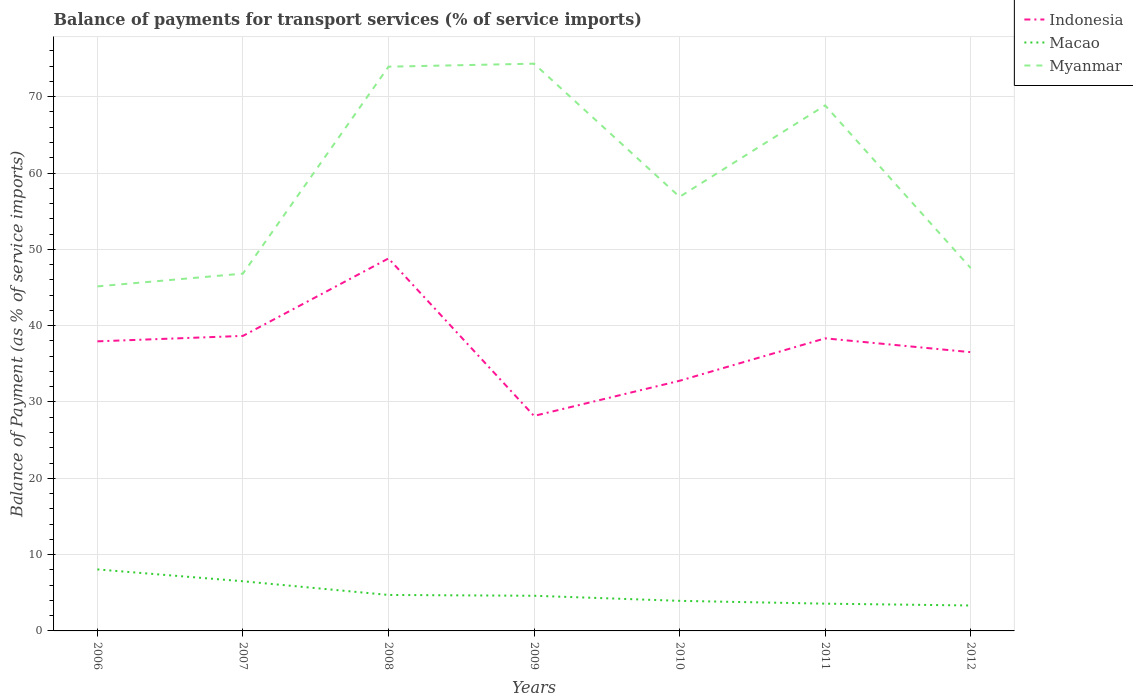How many different coloured lines are there?
Ensure brevity in your answer.  3. Across all years, what is the maximum balance of payments for transport services in Indonesia?
Your answer should be compact. 28.17. What is the total balance of payments for transport services in Myanmar in the graph?
Your answer should be compact. 21.31. What is the difference between the highest and the second highest balance of payments for transport services in Indonesia?
Make the answer very short. 20.63. What is the difference between the highest and the lowest balance of payments for transport services in Macao?
Offer a very short reply. 2. Is the balance of payments for transport services in Macao strictly greater than the balance of payments for transport services in Myanmar over the years?
Give a very brief answer. Yes. What is the difference between two consecutive major ticks on the Y-axis?
Your answer should be compact. 10. Are the values on the major ticks of Y-axis written in scientific E-notation?
Offer a terse response. No. Does the graph contain grids?
Your response must be concise. Yes. Where does the legend appear in the graph?
Make the answer very short. Top right. How many legend labels are there?
Your response must be concise. 3. What is the title of the graph?
Your answer should be compact. Balance of payments for transport services (% of service imports). What is the label or title of the X-axis?
Your response must be concise. Years. What is the label or title of the Y-axis?
Ensure brevity in your answer.  Balance of Payment (as % of service imports). What is the Balance of Payment (as % of service imports) in Indonesia in 2006?
Your response must be concise. 37.94. What is the Balance of Payment (as % of service imports) of Macao in 2006?
Make the answer very short. 8.06. What is the Balance of Payment (as % of service imports) in Myanmar in 2006?
Your answer should be very brief. 45.14. What is the Balance of Payment (as % of service imports) in Indonesia in 2007?
Your response must be concise. 38.66. What is the Balance of Payment (as % of service imports) in Macao in 2007?
Ensure brevity in your answer.  6.51. What is the Balance of Payment (as % of service imports) in Myanmar in 2007?
Ensure brevity in your answer.  46.82. What is the Balance of Payment (as % of service imports) of Indonesia in 2008?
Offer a very short reply. 48.8. What is the Balance of Payment (as % of service imports) of Macao in 2008?
Your answer should be very brief. 4.71. What is the Balance of Payment (as % of service imports) in Myanmar in 2008?
Keep it short and to the point. 73.93. What is the Balance of Payment (as % of service imports) in Indonesia in 2009?
Offer a very short reply. 28.17. What is the Balance of Payment (as % of service imports) in Macao in 2009?
Make the answer very short. 4.61. What is the Balance of Payment (as % of service imports) of Myanmar in 2009?
Keep it short and to the point. 74.33. What is the Balance of Payment (as % of service imports) in Indonesia in 2010?
Your response must be concise. 32.78. What is the Balance of Payment (as % of service imports) in Macao in 2010?
Provide a succinct answer. 3.94. What is the Balance of Payment (as % of service imports) in Myanmar in 2010?
Make the answer very short. 56.88. What is the Balance of Payment (as % of service imports) in Indonesia in 2011?
Give a very brief answer. 38.34. What is the Balance of Payment (as % of service imports) in Macao in 2011?
Give a very brief answer. 3.57. What is the Balance of Payment (as % of service imports) in Myanmar in 2011?
Your answer should be very brief. 68.86. What is the Balance of Payment (as % of service imports) of Indonesia in 2012?
Your response must be concise. 36.53. What is the Balance of Payment (as % of service imports) in Macao in 2012?
Your response must be concise. 3.33. What is the Balance of Payment (as % of service imports) of Myanmar in 2012?
Make the answer very short. 47.55. Across all years, what is the maximum Balance of Payment (as % of service imports) in Indonesia?
Offer a very short reply. 48.8. Across all years, what is the maximum Balance of Payment (as % of service imports) in Macao?
Offer a terse response. 8.06. Across all years, what is the maximum Balance of Payment (as % of service imports) in Myanmar?
Provide a short and direct response. 74.33. Across all years, what is the minimum Balance of Payment (as % of service imports) in Indonesia?
Provide a succinct answer. 28.17. Across all years, what is the minimum Balance of Payment (as % of service imports) of Macao?
Give a very brief answer. 3.33. Across all years, what is the minimum Balance of Payment (as % of service imports) of Myanmar?
Give a very brief answer. 45.14. What is the total Balance of Payment (as % of service imports) of Indonesia in the graph?
Ensure brevity in your answer.  261.21. What is the total Balance of Payment (as % of service imports) in Macao in the graph?
Make the answer very short. 34.73. What is the total Balance of Payment (as % of service imports) in Myanmar in the graph?
Provide a succinct answer. 413.5. What is the difference between the Balance of Payment (as % of service imports) in Indonesia in 2006 and that in 2007?
Ensure brevity in your answer.  -0.71. What is the difference between the Balance of Payment (as % of service imports) in Macao in 2006 and that in 2007?
Your response must be concise. 1.55. What is the difference between the Balance of Payment (as % of service imports) of Myanmar in 2006 and that in 2007?
Ensure brevity in your answer.  -1.67. What is the difference between the Balance of Payment (as % of service imports) of Indonesia in 2006 and that in 2008?
Ensure brevity in your answer.  -10.86. What is the difference between the Balance of Payment (as % of service imports) of Macao in 2006 and that in 2008?
Offer a terse response. 3.35. What is the difference between the Balance of Payment (as % of service imports) in Myanmar in 2006 and that in 2008?
Your answer should be compact. -28.79. What is the difference between the Balance of Payment (as % of service imports) of Indonesia in 2006 and that in 2009?
Ensure brevity in your answer.  9.77. What is the difference between the Balance of Payment (as % of service imports) in Macao in 2006 and that in 2009?
Provide a succinct answer. 3.45. What is the difference between the Balance of Payment (as % of service imports) of Myanmar in 2006 and that in 2009?
Provide a short and direct response. -29.18. What is the difference between the Balance of Payment (as % of service imports) of Indonesia in 2006 and that in 2010?
Your response must be concise. 5.17. What is the difference between the Balance of Payment (as % of service imports) of Macao in 2006 and that in 2010?
Your response must be concise. 4.12. What is the difference between the Balance of Payment (as % of service imports) in Myanmar in 2006 and that in 2010?
Make the answer very short. -11.73. What is the difference between the Balance of Payment (as % of service imports) of Indonesia in 2006 and that in 2011?
Make the answer very short. -0.39. What is the difference between the Balance of Payment (as % of service imports) of Macao in 2006 and that in 2011?
Offer a very short reply. 4.49. What is the difference between the Balance of Payment (as % of service imports) of Myanmar in 2006 and that in 2011?
Make the answer very short. -23.71. What is the difference between the Balance of Payment (as % of service imports) of Indonesia in 2006 and that in 2012?
Your answer should be compact. 1.42. What is the difference between the Balance of Payment (as % of service imports) of Macao in 2006 and that in 2012?
Provide a succinct answer. 4.73. What is the difference between the Balance of Payment (as % of service imports) in Myanmar in 2006 and that in 2012?
Your answer should be very brief. -2.4. What is the difference between the Balance of Payment (as % of service imports) of Indonesia in 2007 and that in 2008?
Give a very brief answer. -10.15. What is the difference between the Balance of Payment (as % of service imports) in Macao in 2007 and that in 2008?
Provide a short and direct response. 1.79. What is the difference between the Balance of Payment (as % of service imports) of Myanmar in 2007 and that in 2008?
Provide a succinct answer. -27.11. What is the difference between the Balance of Payment (as % of service imports) of Indonesia in 2007 and that in 2009?
Provide a succinct answer. 10.48. What is the difference between the Balance of Payment (as % of service imports) in Macao in 2007 and that in 2009?
Provide a short and direct response. 1.9. What is the difference between the Balance of Payment (as % of service imports) in Myanmar in 2007 and that in 2009?
Your answer should be very brief. -27.51. What is the difference between the Balance of Payment (as % of service imports) in Indonesia in 2007 and that in 2010?
Provide a short and direct response. 5.88. What is the difference between the Balance of Payment (as % of service imports) in Macao in 2007 and that in 2010?
Keep it short and to the point. 2.57. What is the difference between the Balance of Payment (as % of service imports) of Myanmar in 2007 and that in 2010?
Give a very brief answer. -10.06. What is the difference between the Balance of Payment (as % of service imports) of Indonesia in 2007 and that in 2011?
Your answer should be very brief. 0.32. What is the difference between the Balance of Payment (as % of service imports) in Macao in 2007 and that in 2011?
Make the answer very short. 2.93. What is the difference between the Balance of Payment (as % of service imports) of Myanmar in 2007 and that in 2011?
Your answer should be compact. -22.04. What is the difference between the Balance of Payment (as % of service imports) of Indonesia in 2007 and that in 2012?
Provide a succinct answer. 2.13. What is the difference between the Balance of Payment (as % of service imports) of Macao in 2007 and that in 2012?
Provide a succinct answer. 3.17. What is the difference between the Balance of Payment (as % of service imports) of Myanmar in 2007 and that in 2012?
Provide a short and direct response. -0.73. What is the difference between the Balance of Payment (as % of service imports) in Indonesia in 2008 and that in 2009?
Ensure brevity in your answer.  20.63. What is the difference between the Balance of Payment (as % of service imports) of Macao in 2008 and that in 2009?
Give a very brief answer. 0.11. What is the difference between the Balance of Payment (as % of service imports) of Myanmar in 2008 and that in 2009?
Ensure brevity in your answer.  -0.4. What is the difference between the Balance of Payment (as % of service imports) of Indonesia in 2008 and that in 2010?
Keep it short and to the point. 16.03. What is the difference between the Balance of Payment (as % of service imports) of Macao in 2008 and that in 2010?
Ensure brevity in your answer.  0.77. What is the difference between the Balance of Payment (as % of service imports) in Myanmar in 2008 and that in 2010?
Ensure brevity in your answer.  17.05. What is the difference between the Balance of Payment (as % of service imports) in Indonesia in 2008 and that in 2011?
Your answer should be compact. 10.47. What is the difference between the Balance of Payment (as % of service imports) of Macao in 2008 and that in 2011?
Make the answer very short. 1.14. What is the difference between the Balance of Payment (as % of service imports) in Myanmar in 2008 and that in 2011?
Offer a terse response. 5.07. What is the difference between the Balance of Payment (as % of service imports) of Indonesia in 2008 and that in 2012?
Your answer should be compact. 12.28. What is the difference between the Balance of Payment (as % of service imports) in Macao in 2008 and that in 2012?
Offer a very short reply. 1.38. What is the difference between the Balance of Payment (as % of service imports) of Myanmar in 2008 and that in 2012?
Offer a very short reply. 26.39. What is the difference between the Balance of Payment (as % of service imports) of Indonesia in 2009 and that in 2010?
Ensure brevity in your answer.  -4.6. What is the difference between the Balance of Payment (as % of service imports) of Macao in 2009 and that in 2010?
Offer a terse response. 0.67. What is the difference between the Balance of Payment (as % of service imports) in Myanmar in 2009 and that in 2010?
Give a very brief answer. 17.45. What is the difference between the Balance of Payment (as % of service imports) of Indonesia in 2009 and that in 2011?
Make the answer very short. -10.16. What is the difference between the Balance of Payment (as % of service imports) of Macao in 2009 and that in 2011?
Provide a succinct answer. 1.03. What is the difference between the Balance of Payment (as % of service imports) in Myanmar in 2009 and that in 2011?
Your answer should be very brief. 5.47. What is the difference between the Balance of Payment (as % of service imports) of Indonesia in 2009 and that in 2012?
Your answer should be compact. -8.35. What is the difference between the Balance of Payment (as % of service imports) of Macao in 2009 and that in 2012?
Offer a very short reply. 1.27. What is the difference between the Balance of Payment (as % of service imports) in Myanmar in 2009 and that in 2012?
Keep it short and to the point. 26.78. What is the difference between the Balance of Payment (as % of service imports) of Indonesia in 2010 and that in 2011?
Your answer should be very brief. -5.56. What is the difference between the Balance of Payment (as % of service imports) of Macao in 2010 and that in 2011?
Your response must be concise. 0.37. What is the difference between the Balance of Payment (as % of service imports) of Myanmar in 2010 and that in 2011?
Keep it short and to the point. -11.98. What is the difference between the Balance of Payment (as % of service imports) of Indonesia in 2010 and that in 2012?
Ensure brevity in your answer.  -3.75. What is the difference between the Balance of Payment (as % of service imports) of Macao in 2010 and that in 2012?
Provide a short and direct response. 0.61. What is the difference between the Balance of Payment (as % of service imports) in Myanmar in 2010 and that in 2012?
Give a very brief answer. 9.33. What is the difference between the Balance of Payment (as % of service imports) in Indonesia in 2011 and that in 2012?
Offer a terse response. 1.81. What is the difference between the Balance of Payment (as % of service imports) in Macao in 2011 and that in 2012?
Provide a short and direct response. 0.24. What is the difference between the Balance of Payment (as % of service imports) in Myanmar in 2011 and that in 2012?
Your answer should be very brief. 21.31. What is the difference between the Balance of Payment (as % of service imports) in Indonesia in 2006 and the Balance of Payment (as % of service imports) in Macao in 2007?
Your answer should be compact. 31.44. What is the difference between the Balance of Payment (as % of service imports) in Indonesia in 2006 and the Balance of Payment (as % of service imports) in Myanmar in 2007?
Offer a terse response. -8.87. What is the difference between the Balance of Payment (as % of service imports) of Macao in 2006 and the Balance of Payment (as % of service imports) of Myanmar in 2007?
Provide a succinct answer. -38.76. What is the difference between the Balance of Payment (as % of service imports) in Indonesia in 2006 and the Balance of Payment (as % of service imports) in Macao in 2008?
Ensure brevity in your answer.  33.23. What is the difference between the Balance of Payment (as % of service imports) in Indonesia in 2006 and the Balance of Payment (as % of service imports) in Myanmar in 2008?
Offer a very short reply. -35.99. What is the difference between the Balance of Payment (as % of service imports) in Macao in 2006 and the Balance of Payment (as % of service imports) in Myanmar in 2008?
Give a very brief answer. -65.87. What is the difference between the Balance of Payment (as % of service imports) of Indonesia in 2006 and the Balance of Payment (as % of service imports) of Macao in 2009?
Your response must be concise. 33.34. What is the difference between the Balance of Payment (as % of service imports) in Indonesia in 2006 and the Balance of Payment (as % of service imports) in Myanmar in 2009?
Your answer should be very brief. -36.38. What is the difference between the Balance of Payment (as % of service imports) of Macao in 2006 and the Balance of Payment (as % of service imports) of Myanmar in 2009?
Give a very brief answer. -66.27. What is the difference between the Balance of Payment (as % of service imports) of Indonesia in 2006 and the Balance of Payment (as % of service imports) of Macao in 2010?
Offer a very short reply. 34. What is the difference between the Balance of Payment (as % of service imports) of Indonesia in 2006 and the Balance of Payment (as % of service imports) of Myanmar in 2010?
Provide a short and direct response. -18.93. What is the difference between the Balance of Payment (as % of service imports) in Macao in 2006 and the Balance of Payment (as % of service imports) in Myanmar in 2010?
Provide a short and direct response. -48.82. What is the difference between the Balance of Payment (as % of service imports) of Indonesia in 2006 and the Balance of Payment (as % of service imports) of Macao in 2011?
Provide a succinct answer. 34.37. What is the difference between the Balance of Payment (as % of service imports) of Indonesia in 2006 and the Balance of Payment (as % of service imports) of Myanmar in 2011?
Offer a terse response. -30.92. What is the difference between the Balance of Payment (as % of service imports) of Macao in 2006 and the Balance of Payment (as % of service imports) of Myanmar in 2011?
Make the answer very short. -60.8. What is the difference between the Balance of Payment (as % of service imports) in Indonesia in 2006 and the Balance of Payment (as % of service imports) in Macao in 2012?
Ensure brevity in your answer.  34.61. What is the difference between the Balance of Payment (as % of service imports) of Indonesia in 2006 and the Balance of Payment (as % of service imports) of Myanmar in 2012?
Your answer should be compact. -9.6. What is the difference between the Balance of Payment (as % of service imports) of Macao in 2006 and the Balance of Payment (as % of service imports) of Myanmar in 2012?
Your response must be concise. -39.49. What is the difference between the Balance of Payment (as % of service imports) of Indonesia in 2007 and the Balance of Payment (as % of service imports) of Macao in 2008?
Make the answer very short. 33.94. What is the difference between the Balance of Payment (as % of service imports) of Indonesia in 2007 and the Balance of Payment (as % of service imports) of Myanmar in 2008?
Ensure brevity in your answer.  -35.27. What is the difference between the Balance of Payment (as % of service imports) of Macao in 2007 and the Balance of Payment (as % of service imports) of Myanmar in 2008?
Keep it short and to the point. -67.42. What is the difference between the Balance of Payment (as % of service imports) of Indonesia in 2007 and the Balance of Payment (as % of service imports) of Macao in 2009?
Provide a succinct answer. 34.05. What is the difference between the Balance of Payment (as % of service imports) of Indonesia in 2007 and the Balance of Payment (as % of service imports) of Myanmar in 2009?
Offer a very short reply. -35.67. What is the difference between the Balance of Payment (as % of service imports) of Macao in 2007 and the Balance of Payment (as % of service imports) of Myanmar in 2009?
Your response must be concise. -67.82. What is the difference between the Balance of Payment (as % of service imports) in Indonesia in 2007 and the Balance of Payment (as % of service imports) in Macao in 2010?
Keep it short and to the point. 34.71. What is the difference between the Balance of Payment (as % of service imports) of Indonesia in 2007 and the Balance of Payment (as % of service imports) of Myanmar in 2010?
Provide a succinct answer. -18.22. What is the difference between the Balance of Payment (as % of service imports) of Macao in 2007 and the Balance of Payment (as % of service imports) of Myanmar in 2010?
Provide a short and direct response. -50.37. What is the difference between the Balance of Payment (as % of service imports) of Indonesia in 2007 and the Balance of Payment (as % of service imports) of Macao in 2011?
Ensure brevity in your answer.  35.08. What is the difference between the Balance of Payment (as % of service imports) in Indonesia in 2007 and the Balance of Payment (as % of service imports) in Myanmar in 2011?
Provide a succinct answer. -30.2. What is the difference between the Balance of Payment (as % of service imports) of Macao in 2007 and the Balance of Payment (as % of service imports) of Myanmar in 2011?
Offer a terse response. -62.35. What is the difference between the Balance of Payment (as % of service imports) in Indonesia in 2007 and the Balance of Payment (as % of service imports) in Macao in 2012?
Provide a succinct answer. 35.32. What is the difference between the Balance of Payment (as % of service imports) of Indonesia in 2007 and the Balance of Payment (as % of service imports) of Myanmar in 2012?
Provide a succinct answer. -8.89. What is the difference between the Balance of Payment (as % of service imports) of Macao in 2007 and the Balance of Payment (as % of service imports) of Myanmar in 2012?
Your response must be concise. -41.04. What is the difference between the Balance of Payment (as % of service imports) of Indonesia in 2008 and the Balance of Payment (as % of service imports) of Macao in 2009?
Offer a very short reply. 44.2. What is the difference between the Balance of Payment (as % of service imports) in Indonesia in 2008 and the Balance of Payment (as % of service imports) in Myanmar in 2009?
Keep it short and to the point. -25.52. What is the difference between the Balance of Payment (as % of service imports) of Macao in 2008 and the Balance of Payment (as % of service imports) of Myanmar in 2009?
Your response must be concise. -69.61. What is the difference between the Balance of Payment (as % of service imports) in Indonesia in 2008 and the Balance of Payment (as % of service imports) in Macao in 2010?
Offer a terse response. 44.86. What is the difference between the Balance of Payment (as % of service imports) of Indonesia in 2008 and the Balance of Payment (as % of service imports) of Myanmar in 2010?
Give a very brief answer. -8.07. What is the difference between the Balance of Payment (as % of service imports) of Macao in 2008 and the Balance of Payment (as % of service imports) of Myanmar in 2010?
Provide a short and direct response. -52.16. What is the difference between the Balance of Payment (as % of service imports) of Indonesia in 2008 and the Balance of Payment (as % of service imports) of Macao in 2011?
Provide a succinct answer. 45.23. What is the difference between the Balance of Payment (as % of service imports) of Indonesia in 2008 and the Balance of Payment (as % of service imports) of Myanmar in 2011?
Provide a short and direct response. -20.05. What is the difference between the Balance of Payment (as % of service imports) of Macao in 2008 and the Balance of Payment (as % of service imports) of Myanmar in 2011?
Your answer should be very brief. -64.15. What is the difference between the Balance of Payment (as % of service imports) of Indonesia in 2008 and the Balance of Payment (as % of service imports) of Macao in 2012?
Your answer should be very brief. 45.47. What is the difference between the Balance of Payment (as % of service imports) of Indonesia in 2008 and the Balance of Payment (as % of service imports) of Myanmar in 2012?
Keep it short and to the point. 1.26. What is the difference between the Balance of Payment (as % of service imports) in Macao in 2008 and the Balance of Payment (as % of service imports) in Myanmar in 2012?
Provide a succinct answer. -42.83. What is the difference between the Balance of Payment (as % of service imports) of Indonesia in 2009 and the Balance of Payment (as % of service imports) of Macao in 2010?
Your answer should be compact. 24.23. What is the difference between the Balance of Payment (as % of service imports) of Indonesia in 2009 and the Balance of Payment (as % of service imports) of Myanmar in 2010?
Your answer should be very brief. -28.7. What is the difference between the Balance of Payment (as % of service imports) in Macao in 2009 and the Balance of Payment (as % of service imports) in Myanmar in 2010?
Your response must be concise. -52.27. What is the difference between the Balance of Payment (as % of service imports) of Indonesia in 2009 and the Balance of Payment (as % of service imports) of Macao in 2011?
Ensure brevity in your answer.  24.6. What is the difference between the Balance of Payment (as % of service imports) of Indonesia in 2009 and the Balance of Payment (as % of service imports) of Myanmar in 2011?
Ensure brevity in your answer.  -40.69. What is the difference between the Balance of Payment (as % of service imports) in Macao in 2009 and the Balance of Payment (as % of service imports) in Myanmar in 2011?
Your response must be concise. -64.25. What is the difference between the Balance of Payment (as % of service imports) of Indonesia in 2009 and the Balance of Payment (as % of service imports) of Macao in 2012?
Make the answer very short. 24.84. What is the difference between the Balance of Payment (as % of service imports) of Indonesia in 2009 and the Balance of Payment (as % of service imports) of Myanmar in 2012?
Offer a terse response. -19.37. What is the difference between the Balance of Payment (as % of service imports) in Macao in 2009 and the Balance of Payment (as % of service imports) in Myanmar in 2012?
Give a very brief answer. -42.94. What is the difference between the Balance of Payment (as % of service imports) of Indonesia in 2010 and the Balance of Payment (as % of service imports) of Macao in 2011?
Your answer should be very brief. 29.2. What is the difference between the Balance of Payment (as % of service imports) in Indonesia in 2010 and the Balance of Payment (as % of service imports) in Myanmar in 2011?
Ensure brevity in your answer.  -36.08. What is the difference between the Balance of Payment (as % of service imports) in Macao in 2010 and the Balance of Payment (as % of service imports) in Myanmar in 2011?
Provide a short and direct response. -64.92. What is the difference between the Balance of Payment (as % of service imports) of Indonesia in 2010 and the Balance of Payment (as % of service imports) of Macao in 2012?
Offer a terse response. 29.44. What is the difference between the Balance of Payment (as % of service imports) in Indonesia in 2010 and the Balance of Payment (as % of service imports) in Myanmar in 2012?
Provide a short and direct response. -14.77. What is the difference between the Balance of Payment (as % of service imports) of Macao in 2010 and the Balance of Payment (as % of service imports) of Myanmar in 2012?
Give a very brief answer. -43.6. What is the difference between the Balance of Payment (as % of service imports) in Indonesia in 2011 and the Balance of Payment (as % of service imports) in Macao in 2012?
Provide a short and direct response. 35. What is the difference between the Balance of Payment (as % of service imports) in Indonesia in 2011 and the Balance of Payment (as % of service imports) in Myanmar in 2012?
Your response must be concise. -9.21. What is the difference between the Balance of Payment (as % of service imports) of Macao in 2011 and the Balance of Payment (as % of service imports) of Myanmar in 2012?
Provide a succinct answer. -43.97. What is the average Balance of Payment (as % of service imports) in Indonesia per year?
Keep it short and to the point. 37.32. What is the average Balance of Payment (as % of service imports) in Macao per year?
Offer a terse response. 4.96. What is the average Balance of Payment (as % of service imports) in Myanmar per year?
Provide a short and direct response. 59.07. In the year 2006, what is the difference between the Balance of Payment (as % of service imports) of Indonesia and Balance of Payment (as % of service imports) of Macao?
Your response must be concise. 29.88. In the year 2006, what is the difference between the Balance of Payment (as % of service imports) in Indonesia and Balance of Payment (as % of service imports) in Myanmar?
Your answer should be very brief. -7.2. In the year 2006, what is the difference between the Balance of Payment (as % of service imports) in Macao and Balance of Payment (as % of service imports) in Myanmar?
Your response must be concise. -37.09. In the year 2007, what is the difference between the Balance of Payment (as % of service imports) of Indonesia and Balance of Payment (as % of service imports) of Macao?
Keep it short and to the point. 32.15. In the year 2007, what is the difference between the Balance of Payment (as % of service imports) in Indonesia and Balance of Payment (as % of service imports) in Myanmar?
Provide a succinct answer. -8.16. In the year 2007, what is the difference between the Balance of Payment (as % of service imports) of Macao and Balance of Payment (as % of service imports) of Myanmar?
Your response must be concise. -40.31. In the year 2008, what is the difference between the Balance of Payment (as % of service imports) in Indonesia and Balance of Payment (as % of service imports) in Macao?
Your response must be concise. 44.09. In the year 2008, what is the difference between the Balance of Payment (as % of service imports) of Indonesia and Balance of Payment (as % of service imports) of Myanmar?
Provide a succinct answer. -25.13. In the year 2008, what is the difference between the Balance of Payment (as % of service imports) of Macao and Balance of Payment (as % of service imports) of Myanmar?
Your answer should be compact. -69.22. In the year 2009, what is the difference between the Balance of Payment (as % of service imports) in Indonesia and Balance of Payment (as % of service imports) in Macao?
Offer a very short reply. 23.57. In the year 2009, what is the difference between the Balance of Payment (as % of service imports) in Indonesia and Balance of Payment (as % of service imports) in Myanmar?
Provide a short and direct response. -46.15. In the year 2009, what is the difference between the Balance of Payment (as % of service imports) in Macao and Balance of Payment (as % of service imports) in Myanmar?
Provide a succinct answer. -69.72. In the year 2010, what is the difference between the Balance of Payment (as % of service imports) in Indonesia and Balance of Payment (as % of service imports) in Macao?
Provide a short and direct response. 28.83. In the year 2010, what is the difference between the Balance of Payment (as % of service imports) of Indonesia and Balance of Payment (as % of service imports) of Myanmar?
Your answer should be compact. -24.1. In the year 2010, what is the difference between the Balance of Payment (as % of service imports) in Macao and Balance of Payment (as % of service imports) in Myanmar?
Your answer should be very brief. -52.94. In the year 2011, what is the difference between the Balance of Payment (as % of service imports) of Indonesia and Balance of Payment (as % of service imports) of Macao?
Offer a very short reply. 34.76. In the year 2011, what is the difference between the Balance of Payment (as % of service imports) of Indonesia and Balance of Payment (as % of service imports) of Myanmar?
Your response must be concise. -30.52. In the year 2011, what is the difference between the Balance of Payment (as % of service imports) of Macao and Balance of Payment (as % of service imports) of Myanmar?
Give a very brief answer. -65.29. In the year 2012, what is the difference between the Balance of Payment (as % of service imports) in Indonesia and Balance of Payment (as % of service imports) in Macao?
Make the answer very short. 33.19. In the year 2012, what is the difference between the Balance of Payment (as % of service imports) of Indonesia and Balance of Payment (as % of service imports) of Myanmar?
Offer a terse response. -11.02. In the year 2012, what is the difference between the Balance of Payment (as % of service imports) in Macao and Balance of Payment (as % of service imports) in Myanmar?
Offer a terse response. -44.21. What is the ratio of the Balance of Payment (as % of service imports) in Indonesia in 2006 to that in 2007?
Offer a terse response. 0.98. What is the ratio of the Balance of Payment (as % of service imports) of Macao in 2006 to that in 2007?
Your answer should be very brief. 1.24. What is the ratio of the Balance of Payment (as % of service imports) of Myanmar in 2006 to that in 2007?
Offer a terse response. 0.96. What is the ratio of the Balance of Payment (as % of service imports) in Indonesia in 2006 to that in 2008?
Make the answer very short. 0.78. What is the ratio of the Balance of Payment (as % of service imports) of Macao in 2006 to that in 2008?
Ensure brevity in your answer.  1.71. What is the ratio of the Balance of Payment (as % of service imports) in Myanmar in 2006 to that in 2008?
Ensure brevity in your answer.  0.61. What is the ratio of the Balance of Payment (as % of service imports) of Indonesia in 2006 to that in 2009?
Your answer should be compact. 1.35. What is the ratio of the Balance of Payment (as % of service imports) of Macao in 2006 to that in 2009?
Keep it short and to the point. 1.75. What is the ratio of the Balance of Payment (as % of service imports) in Myanmar in 2006 to that in 2009?
Ensure brevity in your answer.  0.61. What is the ratio of the Balance of Payment (as % of service imports) of Indonesia in 2006 to that in 2010?
Ensure brevity in your answer.  1.16. What is the ratio of the Balance of Payment (as % of service imports) of Macao in 2006 to that in 2010?
Provide a succinct answer. 2.04. What is the ratio of the Balance of Payment (as % of service imports) of Myanmar in 2006 to that in 2010?
Your answer should be compact. 0.79. What is the ratio of the Balance of Payment (as % of service imports) of Indonesia in 2006 to that in 2011?
Make the answer very short. 0.99. What is the ratio of the Balance of Payment (as % of service imports) in Macao in 2006 to that in 2011?
Ensure brevity in your answer.  2.26. What is the ratio of the Balance of Payment (as % of service imports) in Myanmar in 2006 to that in 2011?
Offer a very short reply. 0.66. What is the ratio of the Balance of Payment (as % of service imports) of Indonesia in 2006 to that in 2012?
Provide a succinct answer. 1.04. What is the ratio of the Balance of Payment (as % of service imports) of Macao in 2006 to that in 2012?
Give a very brief answer. 2.42. What is the ratio of the Balance of Payment (as % of service imports) of Myanmar in 2006 to that in 2012?
Your answer should be very brief. 0.95. What is the ratio of the Balance of Payment (as % of service imports) in Indonesia in 2007 to that in 2008?
Give a very brief answer. 0.79. What is the ratio of the Balance of Payment (as % of service imports) of Macao in 2007 to that in 2008?
Offer a very short reply. 1.38. What is the ratio of the Balance of Payment (as % of service imports) in Myanmar in 2007 to that in 2008?
Make the answer very short. 0.63. What is the ratio of the Balance of Payment (as % of service imports) in Indonesia in 2007 to that in 2009?
Make the answer very short. 1.37. What is the ratio of the Balance of Payment (as % of service imports) in Macao in 2007 to that in 2009?
Provide a succinct answer. 1.41. What is the ratio of the Balance of Payment (as % of service imports) of Myanmar in 2007 to that in 2009?
Offer a terse response. 0.63. What is the ratio of the Balance of Payment (as % of service imports) in Indonesia in 2007 to that in 2010?
Your answer should be compact. 1.18. What is the ratio of the Balance of Payment (as % of service imports) in Macao in 2007 to that in 2010?
Provide a short and direct response. 1.65. What is the ratio of the Balance of Payment (as % of service imports) in Myanmar in 2007 to that in 2010?
Your response must be concise. 0.82. What is the ratio of the Balance of Payment (as % of service imports) of Indonesia in 2007 to that in 2011?
Offer a very short reply. 1.01. What is the ratio of the Balance of Payment (as % of service imports) of Macao in 2007 to that in 2011?
Ensure brevity in your answer.  1.82. What is the ratio of the Balance of Payment (as % of service imports) in Myanmar in 2007 to that in 2011?
Ensure brevity in your answer.  0.68. What is the ratio of the Balance of Payment (as % of service imports) in Indonesia in 2007 to that in 2012?
Your answer should be very brief. 1.06. What is the ratio of the Balance of Payment (as % of service imports) of Macao in 2007 to that in 2012?
Offer a terse response. 1.95. What is the ratio of the Balance of Payment (as % of service imports) in Myanmar in 2007 to that in 2012?
Your answer should be compact. 0.98. What is the ratio of the Balance of Payment (as % of service imports) in Indonesia in 2008 to that in 2009?
Provide a succinct answer. 1.73. What is the ratio of the Balance of Payment (as % of service imports) of Myanmar in 2008 to that in 2009?
Offer a very short reply. 0.99. What is the ratio of the Balance of Payment (as % of service imports) of Indonesia in 2008 to that in 2010?
Your response must be concise. 1.49. What is the ratio of the Balance of Payment (as % of service imports) of Macao in 2008 to that in 2010?
Your answer should be very brief. 1.2. What is the ratio of the Balance of Payment (as % of service imports) in Myanmar in 2008 to that in 2010?
Provide a short and direct response. 1.3. What is the ratio of the Balance of Payment (as % of service imports) of Indonesia in 2008 to that in 2011?
Offer a very short reply. 1.27. What is the ratio of the Balance of Payment (as % of service imports) in Macao in 2008 to that in 2011?
Give a very brief answer. 1.32. What is the ratio of the Balance of Payment (as % of service imports) in Myanmar in 2008 to that in 2011?
Keep it short and to the point. 1.07. What is the ratio of the Balance of Payment (as % of service imports) in Indonesia in 2008 to that in 2012?
Make the answer very short. 1.34. What is the ratio of the Balance of Payment (as % of service imports) of Macao in 2008 to that in 2012?
Provide a short and direct response. 1.41. What is the ratio of the Balance of Payment (as % of service imports) in Myanmar in 2008 to that in 2012?
Ensure brevity in your answer.  1.55. What is the ratio of the Balance of Payment (as % of service imports) in Indonesia in 2009 to that in 2010?
Give a very brief answer. 0.86. What is the ratio of the Balance of Payment (as % of service imports) in Macao in 2009 to that in 2010?
Offer a terse response. 1.17. What is the ratio of the Balance of Payment (as % of service imports) in Myanmar in 2009 to that in 2010?
Ensure brevity in your answer.  1.31. What is the ratio of the Balance of Payment (as % of service imports) in Indonesia in 2009 to that in 2011?
Your response must be concise. 0.73. What is the ratio of the Balance of Payment (as % of service imports) in Macao in 2009 to that in 2011?
Offer a terse response. 1.29. What is the ratio of the Balance of Payment (as % of service imports) in Myanmar in 2009 to that in 2011?
Ensure brevity in your answer.  1.08. What is the ratio of the Balance of Payment (as % of service imports) in Indonesia in 2009 to that in 2012?
Your response must be concise. 0.77. What is the ratio of the Balance of Payment (as % of service imports) of Macao in 2009 to that in 2012?
Your answer should be compact. 1.38. What is the ratio of the Balance of Payment (as % of service imports) of Myanmar in 2009 to that in 2012?
Your answer should be compact. 1.56. What is the ratio of the Balance of Payment (as % of service imports) of Indonesia in 2010 to that in 2011?
Your answer should be very brief. 0.85. What is the ratio of the Balance of Payment (as % of service imports) in Macao in 2010 to that in 2011?
Provide a short and direct response. 1.1. What is the ratio of the Balance of Payment (as % of service imports) of Myanmar in 2010 to that in 2011?
Your answer should be compact. 0.83. What is the ratio of the Balance of Payment (as % of service imports) of Indonesia in 2010 to that in 2012?
Keep it short and to the point. 0.9. What is the ratio of the Balance of Payment (as % of service imports) in Macao in 2010 to that in 2012?
Offer a terse response. 1.18. What is the ratio of the Balance of Payment (as % of service imports) of Myanmar in 2010 to that in 2012?
Keep it short and to the point. 1.2. What is the ratio of the Balance of Payment (as % of service imports) of Indonesia in 2011 to that in 2012?
Your answer should be compact. 1.05. What is the ratio of the Balance of Payment (as % of service imports) in Macao in 2011 to that in 2012?
Your answer should be compact. 1.07. What is the ratio of the Balance of Payment (as % of service imports) of Myanmar in 2011 to that in 2012?
Your answer should be very brief. 1.45. What is the difference between the highest and the second highest Balance of Payment (as % of service imports) in Indonesia?
Your response must be concise. 10.15. What is the difference between the highest and the second highest Balance of Payment (as % of service imports) of Macao?
Provide a short and direct response. 1.55. What is the difference between the highest and the second highest Balance of Payment (as % of service imports) in Myanmar?
Give a very brief answer. 0.4. What is the difference between the highest and the lowest Balance of Payment (as % of service imports) in Indonesia?
Offer a terse response. 20.63. What is the difference between the highest and the lowest Balance of Payment (as % of service imports) in Macao?
Your answer should be compact. 4.73. What is the difference between the highest and the lowest Balance of Payment (as % of service imports) in Myanmar?
Provide a succinct answer. 29.18. 